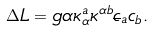Convert formula to latex. <formula><loc_0><loc_0><loc_500><loc_500>\Delta L = g \alpha \kappa ^ { a } _ { \alpha } \kappa ^ { \alpha b } \overline { c } _ { a } c _ { b } .</formula> 